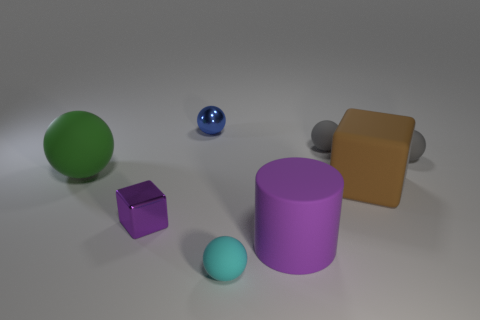Subtract all small gray rubber spheres. How many spheres are left? 3 Add 2 big matte spheres. How many objects exist? 10 Subtract all cyan cylinders. How many gray spheres are left? 2 Subtract all cylinders. How many objects are left? 7 Subtract 3 spheres. How many spheres are left? 2 Subtract all green spheres. How many spheres are left? 4 Subtract all gray cylinders. Subtract all gray blocks. How many cylinders are left? 1 Add 2 large purple cylinders. How many large purple cylinders exist? 3 Subtract 1 brown cubes. How many objects are left? 7 Subtract all cyan cylinders. Subtract all big purple cylinders. How many objects are left? 7 